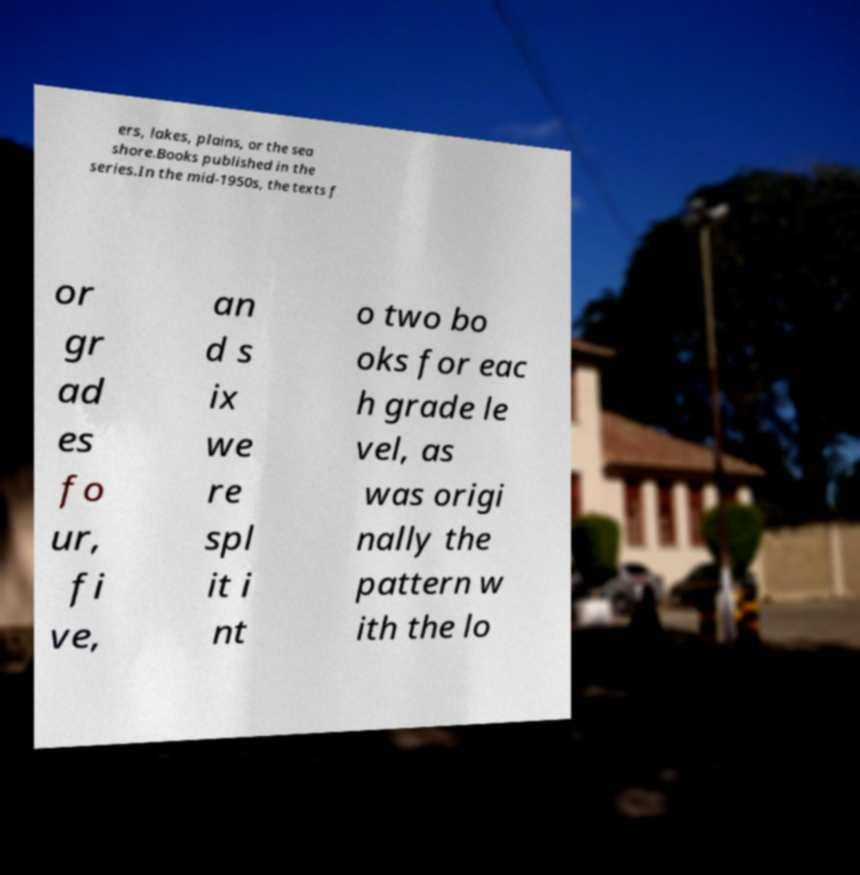Could you assist in decoding the text presented in this image and type it out clearly? ers, lakes, plains, or the sea shore.Books published in the series.In the mid-1950s, the texts f or gr ad es fo ur, fi ve, an d s ix we re spl it i nt o two bo oks for eac h grade le vel, as was origi nally the pattern w ith the lo 